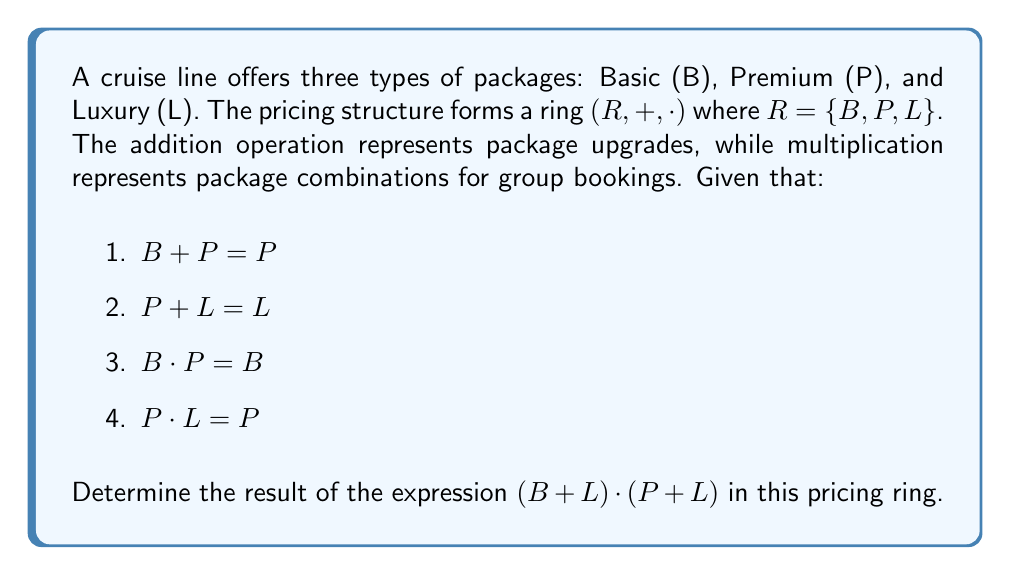Show me your answer to this math problem. To solve this problem, we'll use the properties of rings and the given information to evaluate the expression step by step:

1. First, let's evaluate $B + L$:
   We know that $B + P = P$ and $P + L = L$, so we can deduce that $B + L = L$
   (This follows the principle that upgrading from Basic to Luxury is equivalent to a Luxury package)

2. Next, let's evaluate $P + L$:
   We're given directly that $P + L = L$

3. Now our expression becomes: $L \cdot L$

4. To determine $L \cdot L$, we need to consider the properties of rings:
   - Closure: The result must be in the set $\{B, P, L\}$
   - Associativity: $(a \cdot b) \cdot c = a \cdot (b \cdot c)$
   - Distributivity: $a \cdot (b + c) = (a \cdot b) + (a \cdot c)$

5. Given that $B \cdot P = B$ and $P \cdot L = P$, we can infer that multiplication with a "lower" package results in the lower package. Following this pattern, we can deduce that $L \cdot L = L$

Therefore, $(B + L) \cdot (P + L) = L \cdot L = L$

In the context of cruise pricing, this result suggests that combining a group booking of the highest available upgrade (Luxury) with another Luxury package still results in a Luxury package pricing.
Answer: $L$ 